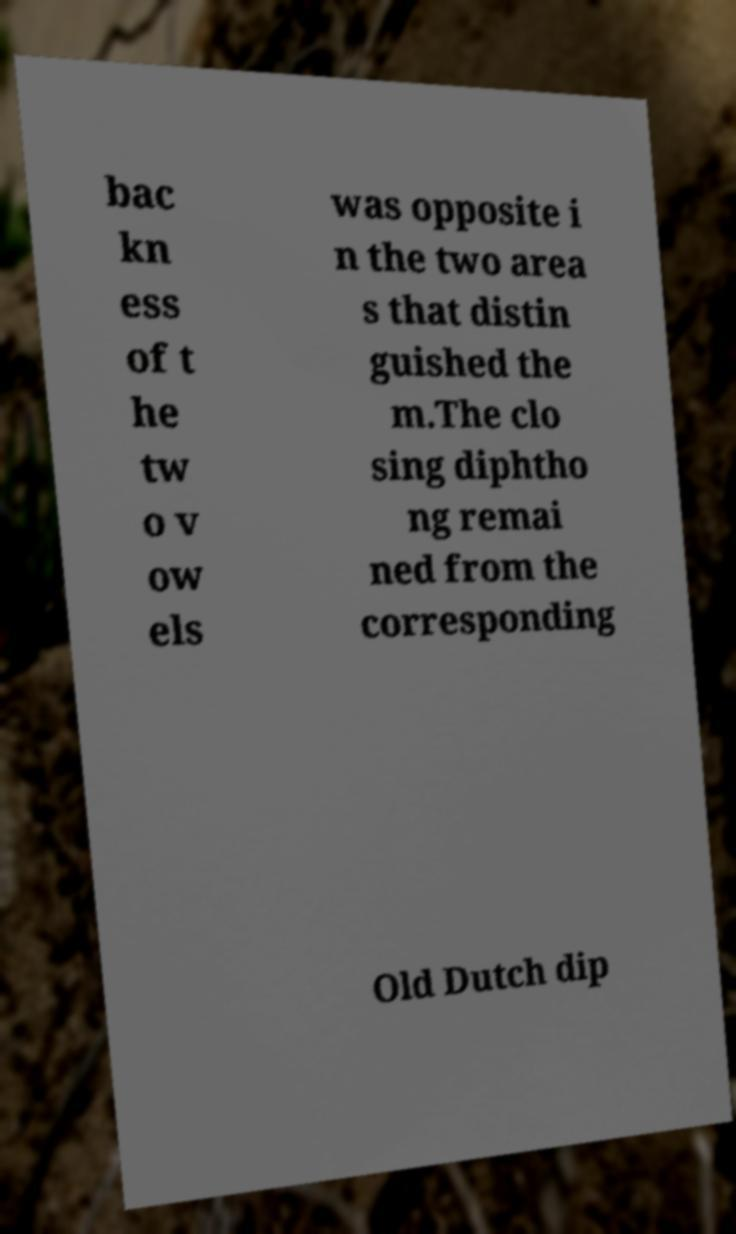Could you extract and type out the text from this image? bac kn ess of t he tw o v ow els was opposite i n the two area s that distin guished the m.The clo sing diphtho ng remai ned from the corresponding Old Dutch dip 